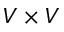<formula> <loc_0><loc_0><loc_500><loc_500>V \times V</formula> 